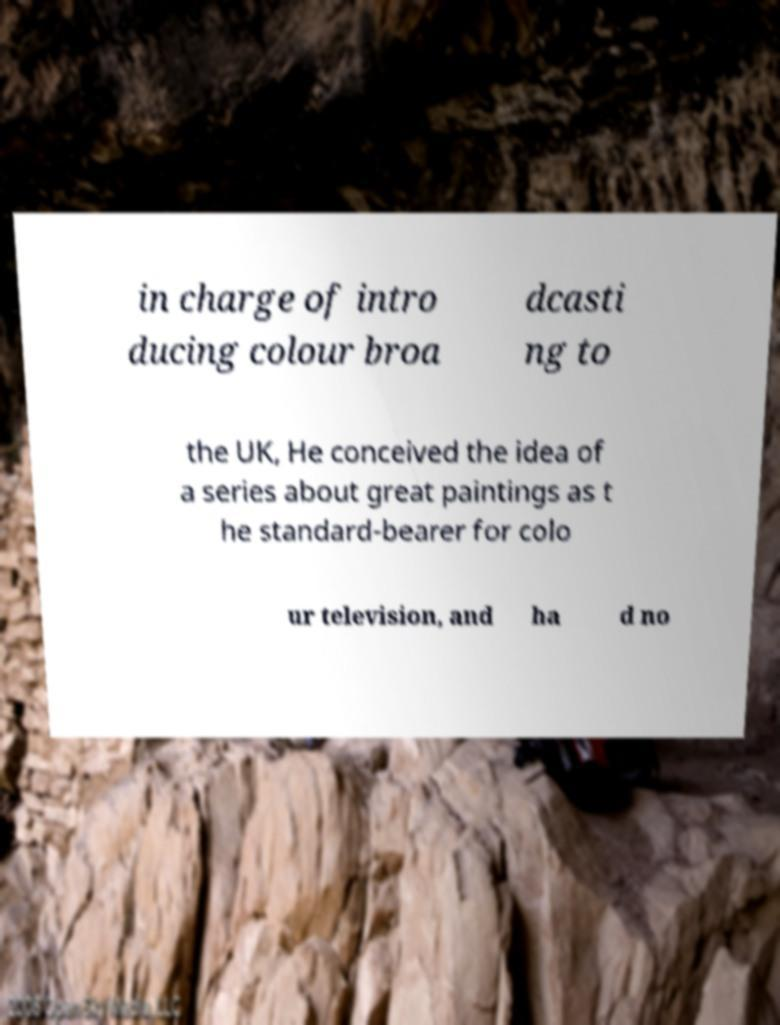I need the written content from this picture converted into text. Can you do that? in charge of intro ducing colour broa dcasti ng to the UK, He conceived the idea of a series about great paintings as t he standard-bearer for colo ur television, and ha d no 